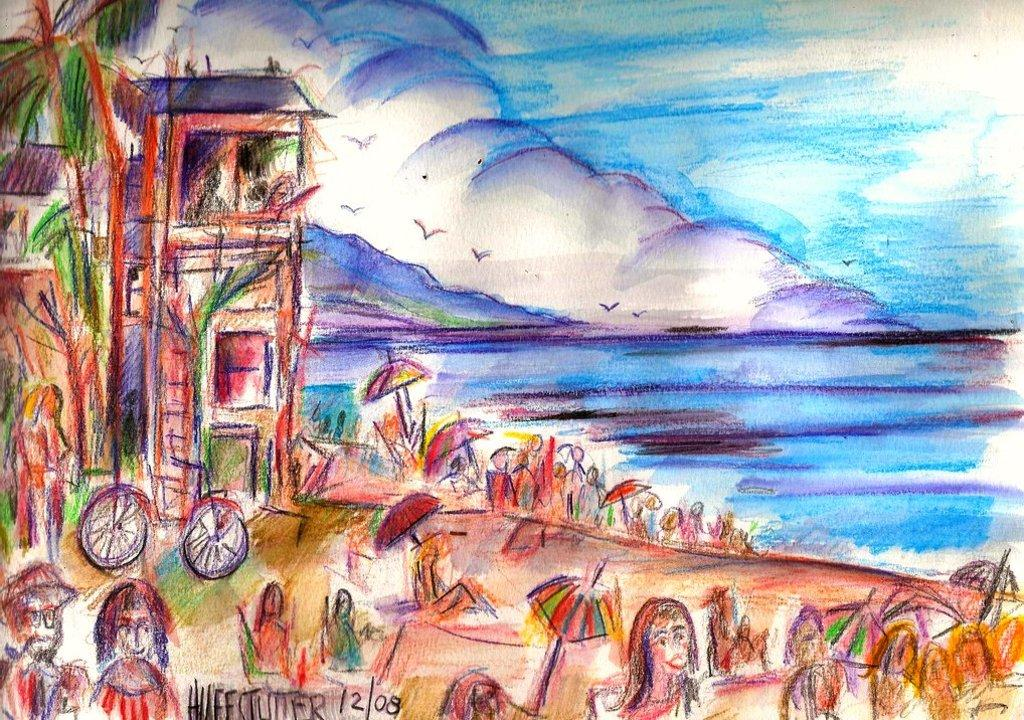What is depicted in the image? There is a drawing in the image. What elements can be found in the drawing? The drawing contains buildings, trees, people, umbrellas, water, birds, and a bicycle. The sky is also visible in the drawing. Can you describe the setting of the drawing? The drawing appears to depict an urban or suburban area with buildings, trees, and people. There is also water present, which could be a river or a body of water. What type of lock is being used by the farmer in the drawing? There is no farmer or lock present in the drawing; it contains buildings, trees, people, umbrellas, water, birds, and a bicycle. How many roses can be seen in the drawing? There are no roses depicted in the drawing; it contains buildings, trees, people, umbrellas, water, birds, and a bicycle. 